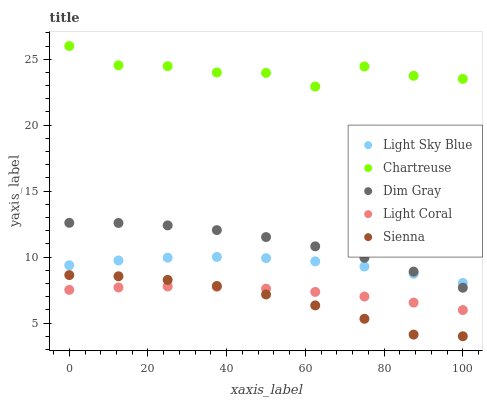Does Sienna have the minimum area under the curve?
Answer yes or no. Yes. Does Chartreuse have the maximum area under the curve?
Answer yes or no. Yes. Does Chartreuse have the minimum area under the curve?
Answer yes or no. No. Does Sienna have the maximum area under the curve?
Answer yes or no. No. Is Light Coral the smoothest?
Answer yes or no. Yes. Is Chartreuse the roughest?
Answer yes or no. Yes. Is Sienna the smoothest?
Answer yes or no. No. Is Sienna the roughest?
Answer yes or no. No. Does Sienna have the lowest value?
Answer yes or no. Yes. Does Chartreuse have the lowest value?
Answer yes or no. No. Does Chartreuse have the highest value?
Answer yes or no. Yes. Does Sienna have the highest value?
Answer yes or no. No. Is Sienna less than Light Sky Blue?
Answer yes or no. Yes. Is Chartreuse greater than Sienna?
Answer yes or no. Yes. Does Dim Gray intersect Light Sky Blue?
Answer yes or no. Yes. Is Dim Gray less than Light Sky Blue?
Answer yes or no. No. Is Dim Gray greater than Light Sky Blue?
Answer yes or no. No. Does Sienna intersect Light Sky Blue?
Answer yes or no. No. 